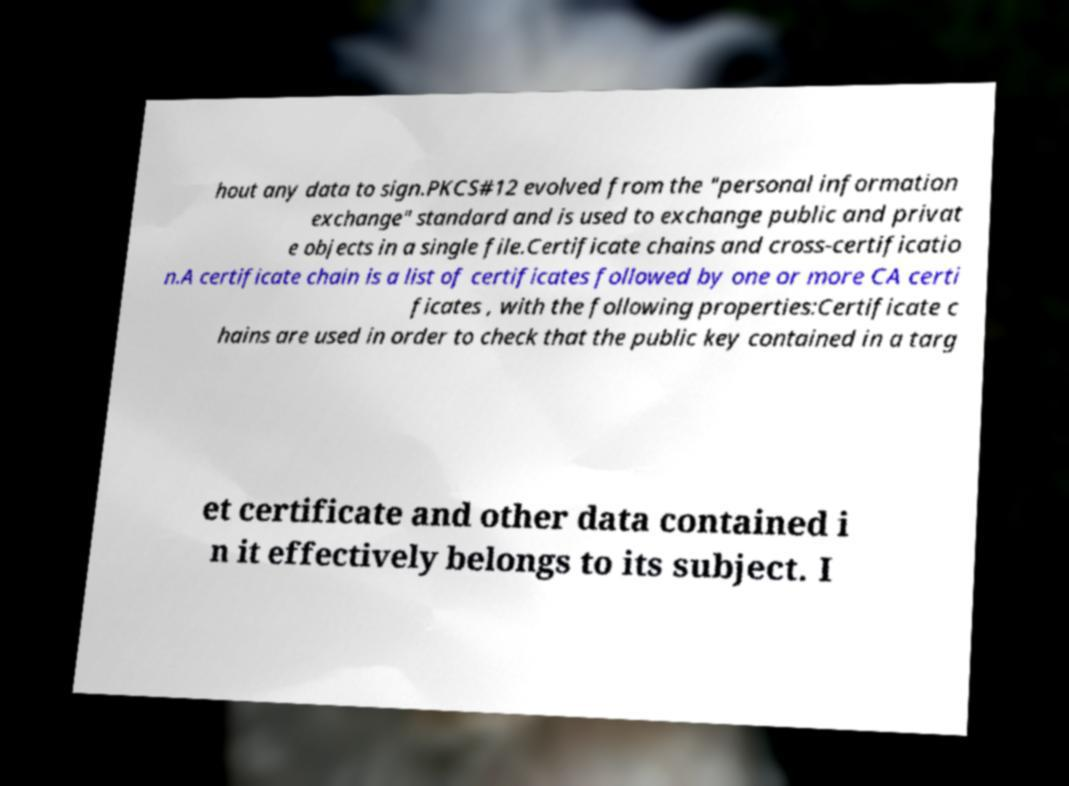What messages or text are displayed in this image? I need them in a readable, typed format. hout any data to sign.PKCS#12 evolved from the "personal information exchange" standard and is used to exchange public and privat e objects in a single file.Certificate chains and cross-certificatio n.A certificate chain is a list of certificates followed by one or more CA certi ficates , with the following properties:Certificate c hains are used in order to check that the public key contained in a targ et certificate and other data contained i n it effectively belongs to its subject. I 